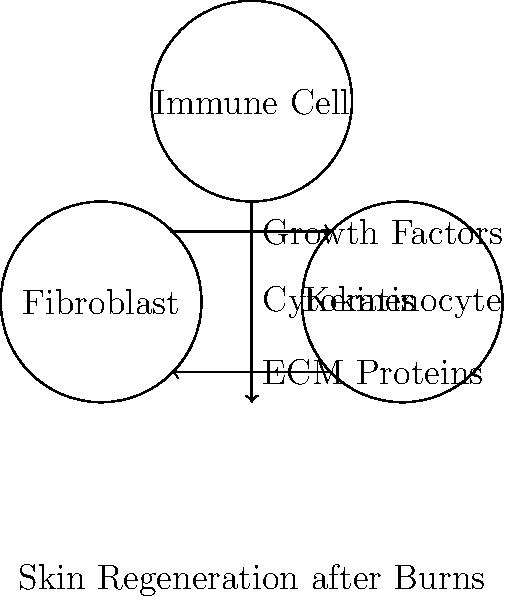In the process of skin regeneration after burns, which cell type is primarily responsible for producing extracellular matrix (ECM) proteins and what is the main function of these proteins in wound healing? 1. Skin regeneration after burns involves complex interactions between various cell types:
   - Fibroblasts
   - Keratinocytes
   - Immune cells

2. Fibroblasts are the primary producers of ECM proteins:
   - They synthesize collagen, elastin, and proteoglycans
   - These proteins form the structural framework of healing tissue

3. ECM proteins have several crucial functions in wound healing:
   - Provide scaffolding for cell migration and attachment
   - Support tissue strength and elasticity
   - Facilitate cell-cell and cell-matrix interactions

4. The process of ECM production and remodeling:
   - Fibroblasts are activated by growth factors and cytokines
   - They proliferate and migrate to the wound site
   - ECM production increases, forming granulation tissue
   - Over time, the ECM is remodeled to restore normal tissue architecture

5. Keratinocytes and immune cells also play important roles:
   - Keratinocytes: re-epithelialization of the wound surface
   - Immune cells: inflammation control and release of growth factors

6. The main function of ECM proteins in wound healing is to provide structural support and facilitate tissue regeneration by:
   - Creating a temporary matrix for cell migration
   - Supporting new blood vessel formation (angiogenesis)
   - Promoting cell differentiation and tissue organization

Therefore, fibroblasts are the primary producers of ECM proteins, which function to provide structural support and facilitate tissue regeneration in burn wound healing.
Answer: Fibroblasts; provide structural support and facilitate tissue regeneration 